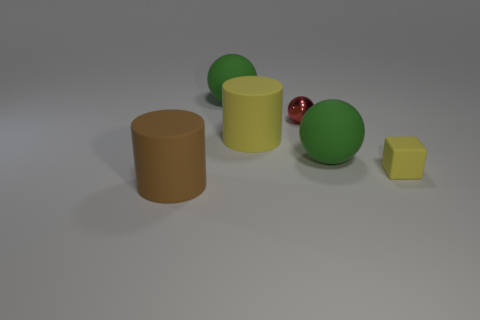There is a green rubber thing that is behind the green matte thing that is in front of the large cylinder that is behind the small yellow matte block; what size is it?
Offer a very short reply. Large. There is a red object; does it have the same size as the rubber cylinder in front of the yellow cube?
Your answer should be very brief. No. Is the number of big green spheres that are to the right of the matte block less than the number of large green rubber balls?
Your answer should be very brief. Yes. How many tiny cubes have the same color as the small metallic sphere?
Offer a terse response. 0. Are there fewer big yellow shiny objects than red spheres?
Give a very brief answer. Yes. Are the yellow cube and the red object made of the same material?
Your answer should be compact. No. What number of other objects are the same size as the yellow cylinder?
Keep it short and to the point. 3. There is a big ball that is in front of the big green ball that is to the left of the large yellow rubber cylinder; what is its color?
Your response must be concise. Green. What number of other things are the same shape as the brown rubber thing?
Provide a succinct answer. 1. Are there any other tiny red balls made of the same material as the red sphere?
Your response must be concise. No. 